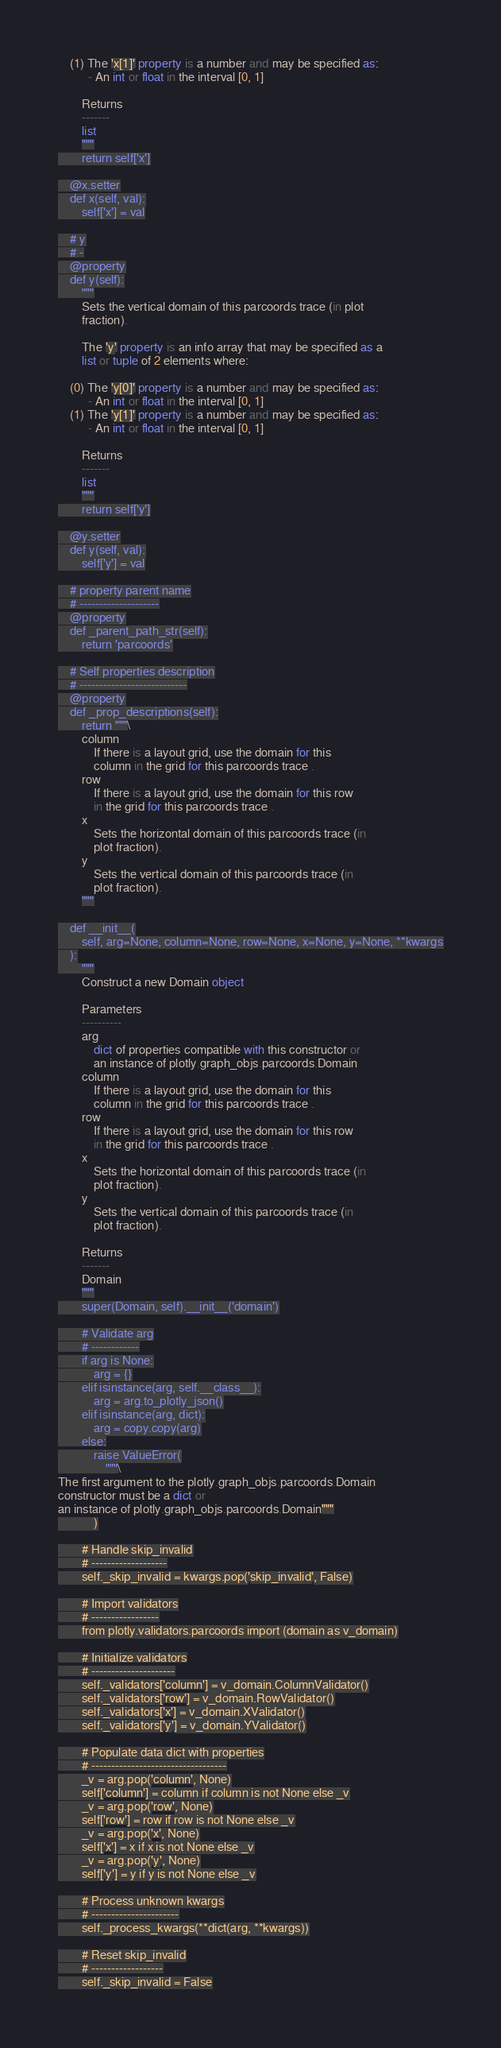<code> <loc_0><loc_0><loc_500><loc_500><_Python_>    (1) The 'x[1]' property is a number and may be specified as:
          - An int or float in the interval [0, 1]

        Returns
        -------
        list
        """
        return self['x']

    @x.setter
    def x(self, val):
        self['x'] = val

    # y
    # -
    @property
    def y(self):
        """
        Sets the vertical domain of this parcoords trace (in plot
        fraction).
    
        The 'y' property is an info array that may be specified as a
        list or tuple of 2 elements where:
    
    (0) The 'y[0]' property is a number and may be specified as:
          - An int or float in the interval [0, 1]
    (1) The 'y[1]' property is a number and may be specified as:
          - An int or float in the interval [0, 1]

        Returns
        -------
        list
        """
        return self['y']

    @y.setter
    def y(self, val):
        self['y'] = val

    # property parent name
    # --------------------
    @property
    def _parent_path_str(self):
        return 'parcoords'

    # Self properties description
    # ---------------------------
    @property
    def _prop_descriptions(self):
        return """\
        column
            If there is a layout grid, use the domain for this
            column in the grid for this parcoords trace .
        row
            If there is a layout grid, use the domain for this row
            in the grid for this parcoords trace .
        x
            Sets the horizontal domain of this parcoords trace (in
            plot fraction).
        y
            Sets the vertical domain of this parcoords trace (in
            plot fraction).
        """

    def __init__(
        self, arg=None, column=None, row=None, x=None, y=None, **kwargs
    ):
        """
        Construct a new Domain object
        
        Parameters
        ----------
        arg
            dict of properties compatible with this constructor or
            an instance of plotly.graph_objs.parcoords.Domain
        column
            If there is a layout grid, use the domain for this
            column in the grid for this parcoords trace .
        row
            If there is a layout grid, use the domain for this row
            in the grid for this parcoords trace .
        x
            Sets the horizontal domain of this parcoords trace (in
            plot fraction).
        y
            Sets the vertical domain of this parcoords trace (in
            plot fraction).

        Returns
        -------
        Domain
        """
        super(Domain, self).__init__('domain')

        # Validate arg
        # ------------
        if arg is None:
            arg = {}
        elif isinstance(arg, self.__class__):
            arg = arg.to_plotly_json()
        elif isinstance(arg, dict):
            arg = copy.copy(arg)
        else:
            raise ValueError(
                """\
The first argument to the plotly.graph_objs.parcoords.Domain 
constructor must be a dict or 
an instance of plotly.graph_objs.parcoords.Domain"""
            )

        # Handle skip_invalid
        # -------------------
        self._skip_invalid = kwargs.pop('skip_invalid', False)

        # Import validators
        # -----------------
        from plotly.validators.parcoords import (domain as v_domain)

        # Initialize validators
        # ---------------------
        self._validators['column'] = v_domain.ColumnValidator()
        self._validators['row'] = v_domain.RowValidator()
        self._validators['x'] = v_domain.XValidator()
        self._validators['y'] = v_domain.YValidator()

        # Populate data dict with properties
        # ----------------------------------
        _v = arg.pop('column', None)
        self['column'] = column if column is not None else _v
        _v = arg.pop('row', None)
        self['row'] = row if row is not None else _v
        _v = arg.pop('x', None)
        self['x'] = x if x is not None else _v
        _v = arg.pop('y', None)
        self['y'] = y if y is not None else _v

        # Process unknown kwargs
        # ----------------------
        self._process_kwargs(**dict(arg, **kwargs))

        # Reset skip_invalid
        # ------------------
        self._skip_invalid = False
</code> 